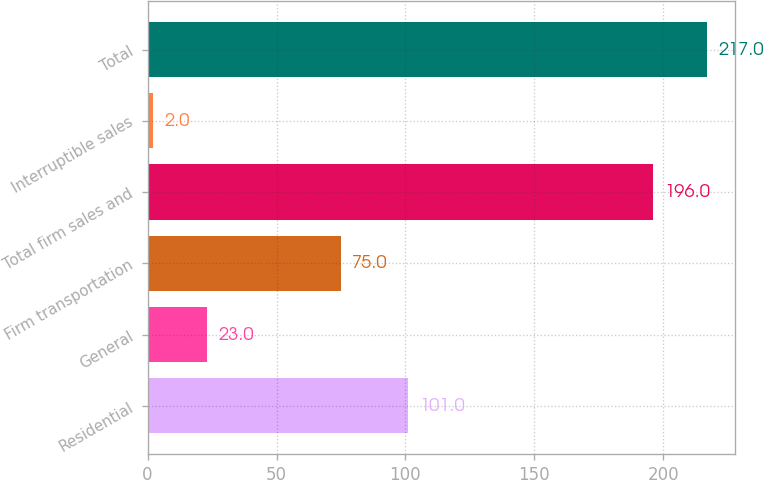Convert chart to OTSL. <chart><loc_0><loc_0><loc_500><loc_500><bar_chart><fcel>Residential<fcel>General<fcel>Firm transportation<fcel>Total firm sales and<fcel>Interruptible sales<fcel>Total<nl><fcel>101<fcel>23<fcel>75<fcel>196<fcel>2<fcel>217<nl></chart> 